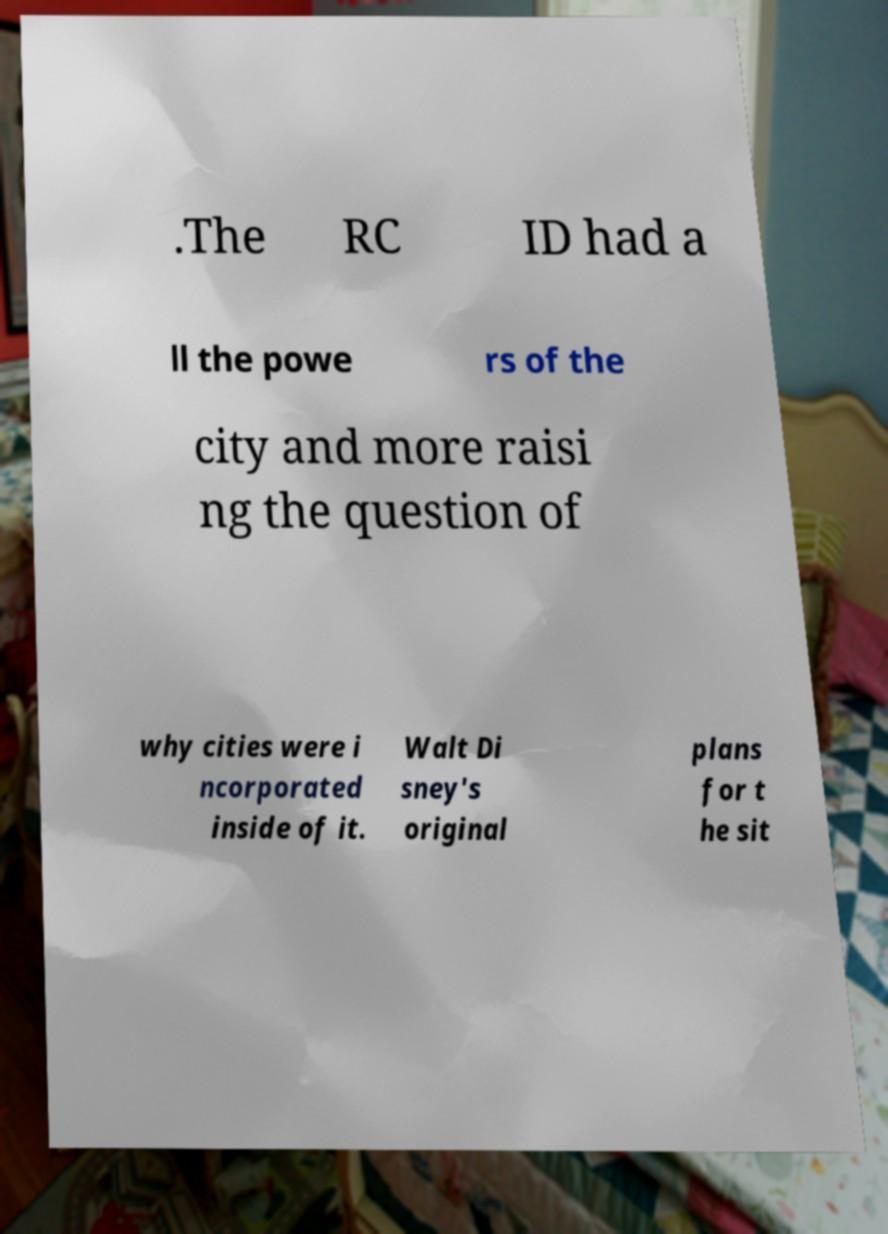For documentation purposes, I need the text within this image transcribed. Could you provide that? .The RC ID had a ll the powe rs of the city and more raisi ng the question of why cities were i ncorporated inside of it. Walt Di sney's original plans for t he sit 